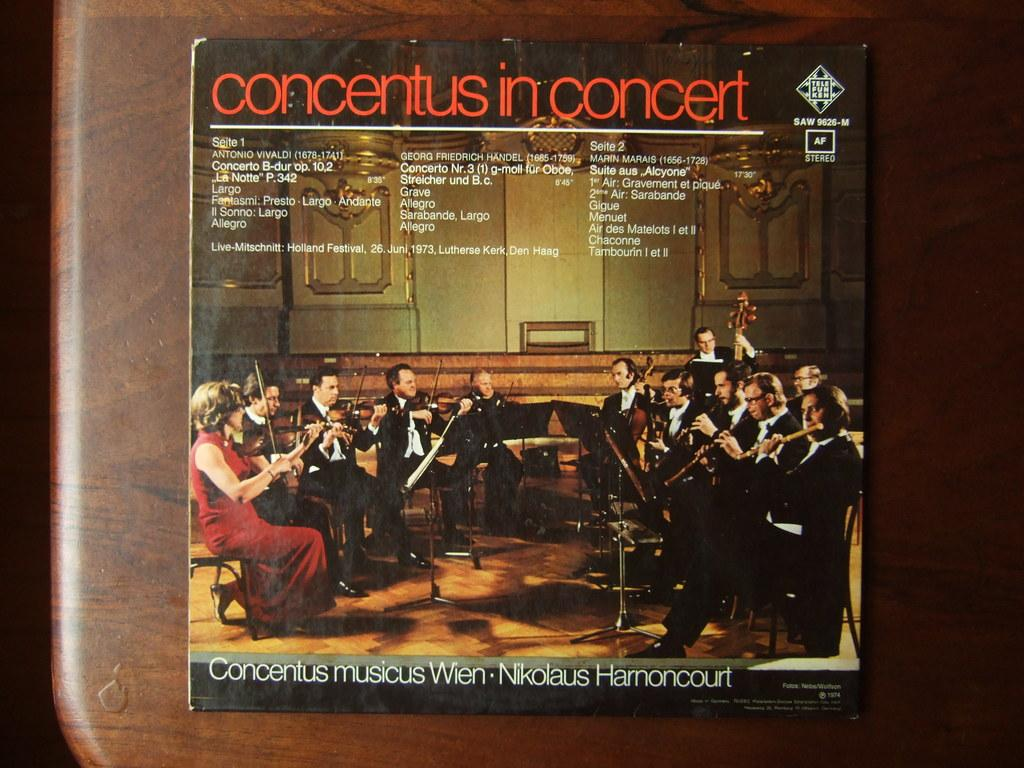<image>
Render a clear and concise summary of the photo. Album cover by Concentus in Concert with various orchestra players. 